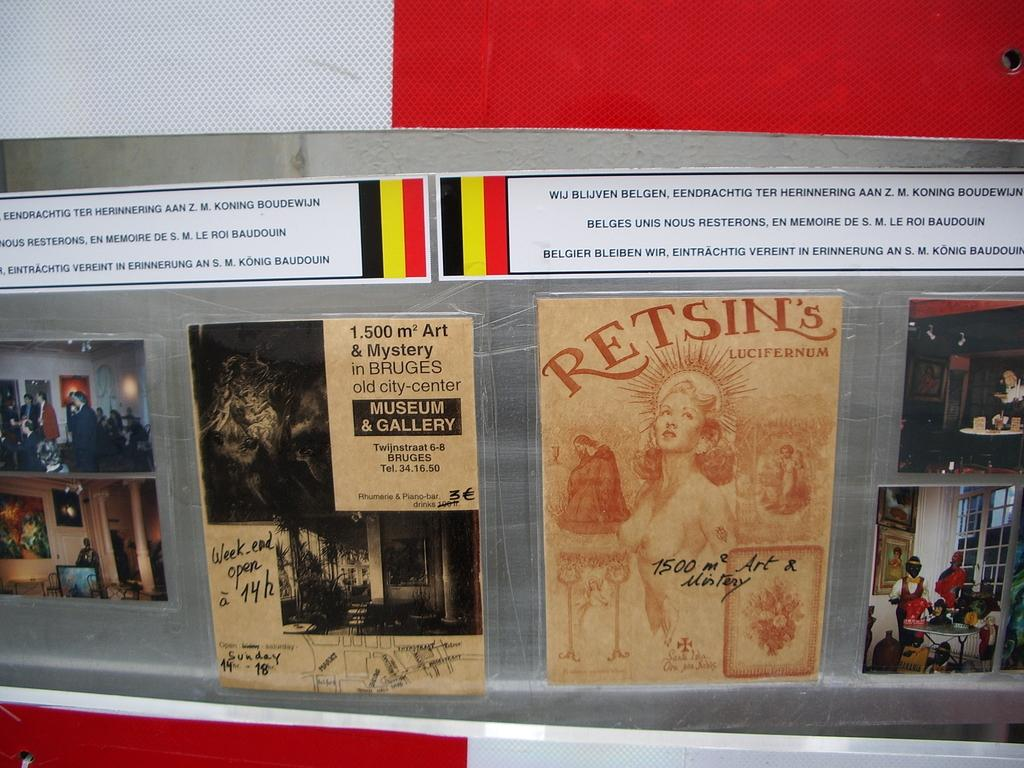<image>
Relay a brief, clear account of the picture shown. the word retsins that is on a brown poster 